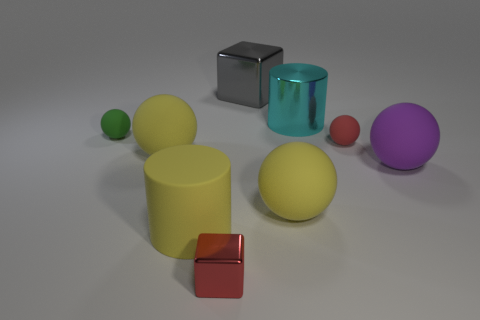How many purple matte balls are behind the metal block that is in front of the small rubber object that is right of the small green thing?
Provide a short and direct response. 1. Is the number of red cubes greater than the number of yellow matte spheres?
Keep it short and to the point. No. What number of large purple matte spheres are there?
Give a very brief answer. 1. The tiny red object in front of the matte ball on the right side of the tiny ball on the right side of the shiny cylinder is what shape?
Provide a short and direct response. Cube. Is the number of small matte balls that are in front of the tiny shiny thing less than the number of large rubber spheres that are behind the large gray shiny cube?
Make the answer very short. No. There is a yellow object on the right side of the big gray object; is its shape the same as the big rubber object that is left of the big yellow cylinder?
Provide a short and direct response. Yes. There is a red thing that is on the right side of the cylinder that is on the right side of the big yellow cylinder; what shape is it?
Keep it short and to the point. Sphere. There is a thing that is the same color as the tiny metallic block; what size is it?
Your answer should be very brief. Small. Are there any green spheres made of the same material as the gray block?
Give a very brief answer. No. There is a big cylinder in front of the green matte thing; what material is it?
Provide a short and direct response. Rubber. 